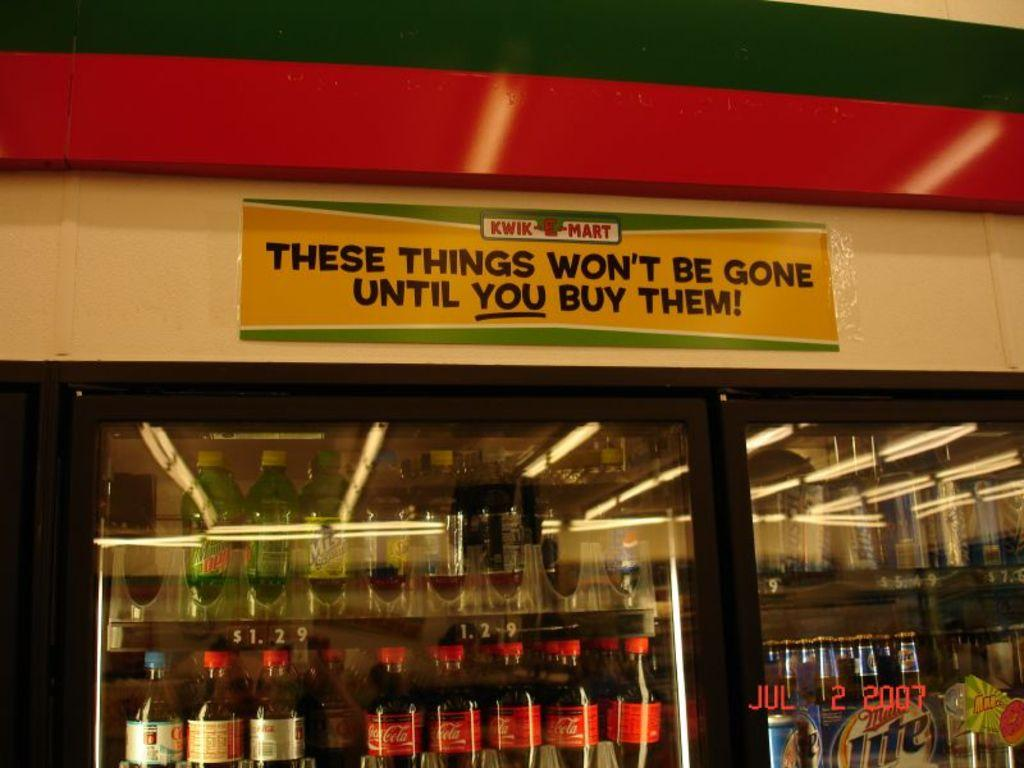Provide a one-sentence caption for the provided image. Freezer in a store with soda inside and a sign on top for "Kwik Mart". 